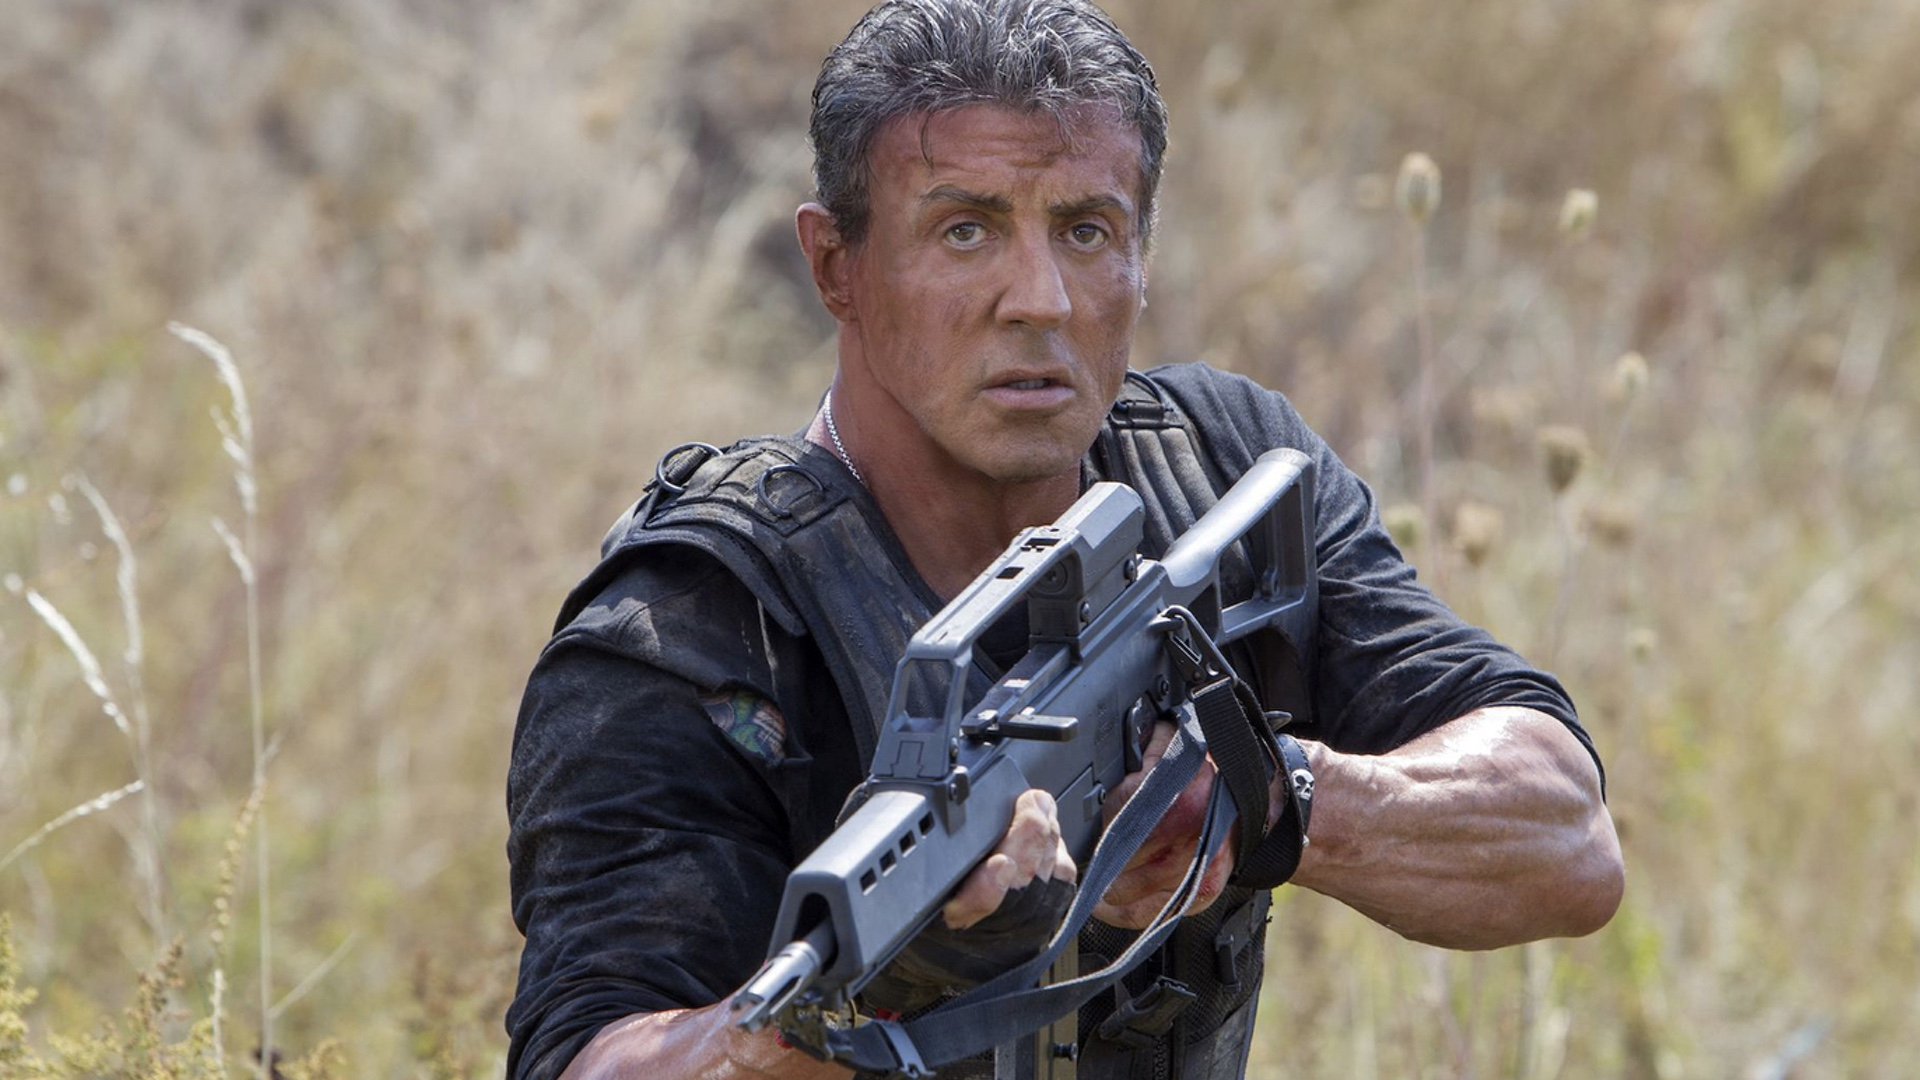Can you elaborate on the elements of the picture provided? In this image, we see the well-known actor portraying a rugged, action-oriented character. The character is standing amidst a field filled with tall grass and wildflowers, creating a stark contrast with his tough appearance. He is gripping a formidable firearm with both hands, displaying a readiness for immediate action. His attire consists of a black combat vest, adding to the starkness against the natural, earthy tones of the backdrop. His facial expression is intense and focused, capturing the seriousness of his situation. This portrayal reflects the character's solitary and prepared nature, epitomizing a constant state of vigilance in a challenging environment. 